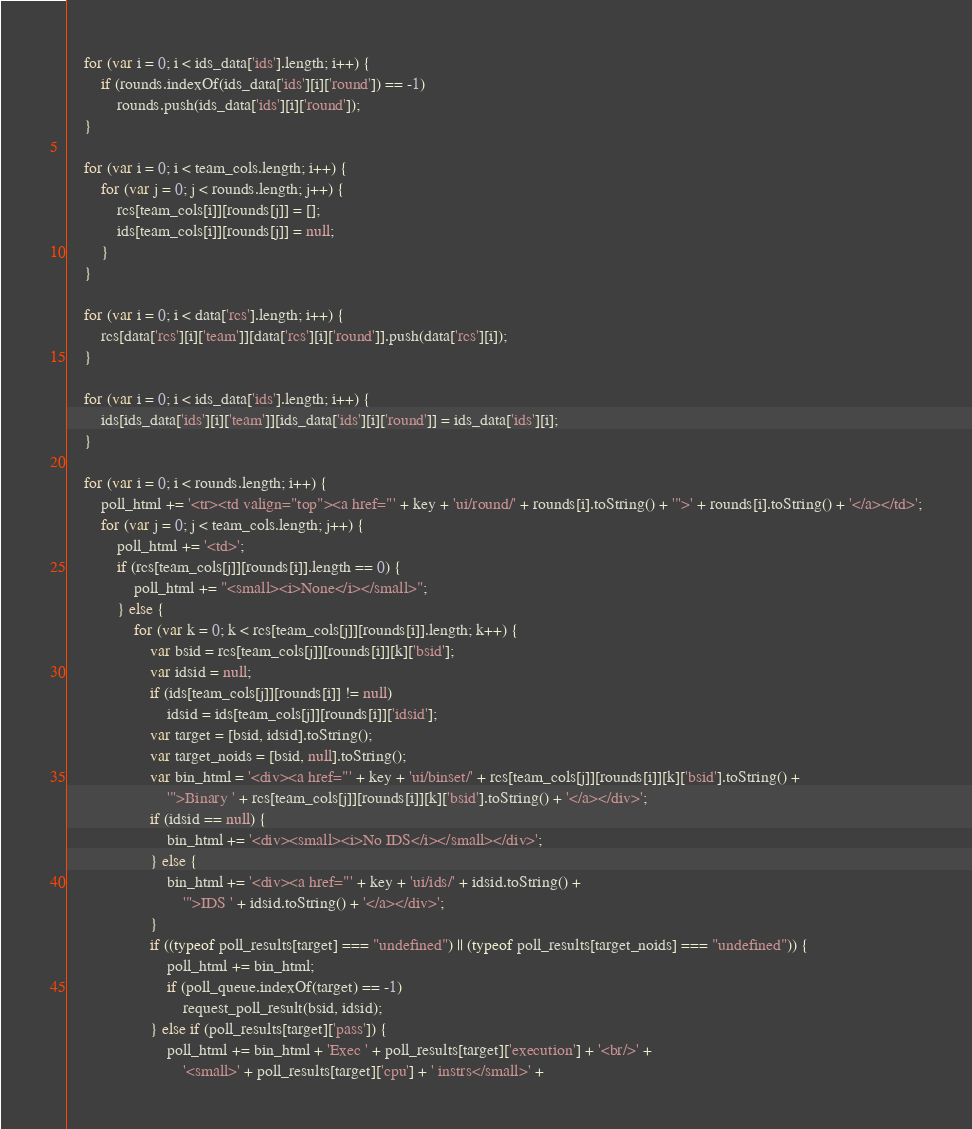Convert code to text. <code><loc_0><loc_0><loc_500><loc_500><_JavaScript_>	for (var i = 0; i < ids_data['ids'].length; i++) {
		if (rounds.indexOf(ids_data['ids'][i]['round']) == -1)
			rounds.push(ids_data['ids'][i]['round']);
	}

	for (var i = 0; i < team_cols.length; i++) {
		for (var j = 0; j < rounds.length; j++) {
			rcs[team_cols[i]][rounds[j]] = [];
			ids[team_cols[i]][rounds[j]] = null;
		}
	}

	for (var i = 0; i < data['rcs'].length; i++) {
		rcs[data['rcs'][i]['team']][data['rcs'][i]['round']].push(data['rcs'][i]);
	}

	for (var i = 0; i < ids_data['ids'].length; i++) {
		ids[ids_data['ids'][i]['team']][ids_data['ids'][i]['round']] = ids_data['ids'][i];
	}

	for (var i = 0; i < rounds.length; i++) {
		poll_html += '<tr><td valign="top"><a href="' + key + 'ui/round/' + rounds[i].toString() + '">' + rounds[i].toString() + '</a></td>';
		for (var j = 0; j < team_cols.length; j++) {
			poll_html += '<td>';
			if (rcs[team_cols[j]][rounds[i]].length == 0) {
				poll_html += "<small><i>None</i></small>";
			} else {
				for (var k = 0; k < rcs[team_cols[j]][rounds[i]].length; k++) {
					var bsid = rcs[team_cols[j]][rounds[i]][k]['bsid'];
					var idsid = null;
					if (ids[team_cols[j]][rounds[i]] != null)
						idsid = ids[team_cols[j]][rounds[i]]['idsid'];
					var target = [bsid, idsid].toString();
					var target_noids = [bsid, null].toString();
					var bin_html = '<div><a href="' + key + 'ui/binset/' + rcs[team_cols[j]][rounds[i]][k]['bsid'].toString() +
						'">Binary ' + rcs[team_cols[j]][rounds[i]][k]['bsid'].toString() + '</a></div>';
					if (idsid == null) {
						bin_html += '<div><small><i>No IDS</i></small></div>';
					} else {
						bin_html += '<div><a href="' + key + 'ui/ids/' + idsid.toString() +
							'">IDS ' + idsid.toString() + '</a></div>';
					}
					if ((typeof poll_results[target] === "undefined") || (typeof poll_results[target_noids] === "undefined")) {
						poll_html += bin_html;
						if (poll_queue.indexOf(target) == -1)
							request_poll_result(bsid, idsid);
					} else if (poll_results[target]['pass']) {
						poll_html += bin_html + 'Exec ' + poll_results[target]['execution'] + '<br/>' +
							'<small>' + poll_results[target]['cpu'] + ' instrs</small>' +</code> 